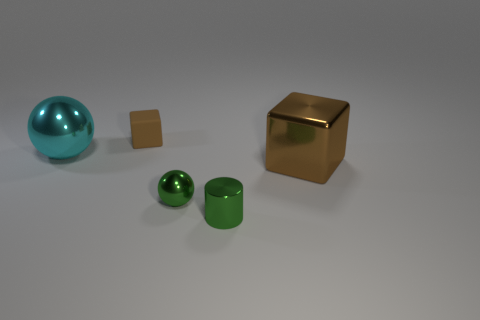Is there any other thing that is the same shape as the tiny matte object?
Provide a succinct answer. Yes. There is a tiny ball that is the same material as the large brown object; what is its color?
Provide a succinct answer. Green. What number of objects are big blue things or large objects?
Your answer should be very brief. 2. Is the size of the matte block the same as the sphere that is on the right side of the large cyan metallic ball?
Give a very brief answer. Yes. There is a metallic ball that is right of the sphere behind the cube that is to the right of the matte thing; what color is it?
Offer a terse response. Green. What color is the rubber object?
Ensure brevity in your answer.  Brown. Are there more big cyan things that are behind the tiny brown cube than green objects that are left of the tiny green shiny cylinder?
Offer a very short reply. No. There is a cyan shiny thing; is its shape the same as the small green metal thing that is to the left of the tiny green cylinder?
Your answer should be very brief. Yes. Does the ball that is to the left of the tiny brown cube have the same size as the brown cube on the right side of the tiny matte object?
Your answer should be compact. Yes. There is a sphere on the left side of the block behind the big cyan shiny ball; are there any cubes behind it?
Ensure brevity in your answer.  Yes. 